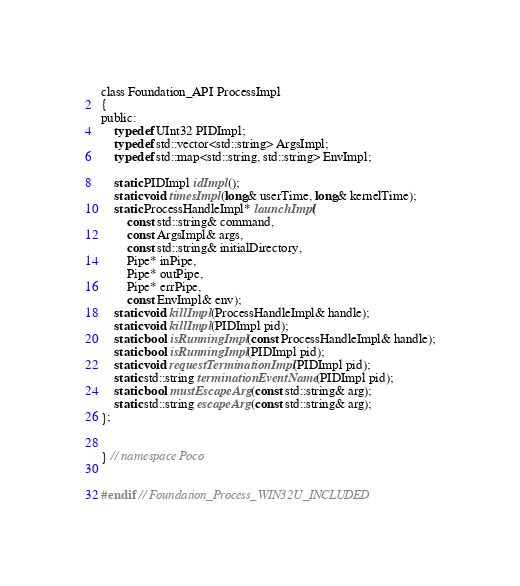<code> <loc_0><loc_0><loc_500><loc_500><_C_>
class Foundation_API ProcessImpl
{
public:
	typedef UInt32 PIDImpl;
	typedef std::vector<std::string> ArgsImpl;
	typedef std::map<std::string, std::string> EnvImpl;

	static PIDImpl idImpl();
	static void timesImpl(long& userTime, long& kernelTime);
	static ProcessHandleImpl* launchImpl(
		const std::string& command,
		const ArgsImpl& args,
		const std::string& initialDirectory,
		Pipe* inPipe,
		Pipe* outPipe,
		Pipe* errPipe,
		const EnvImpl& env);
	static void killImpl(ProcessHandleImpl& handle);
	static void killImpl(PIDImpl pid);
	static bool isRunningImpl(const ProcessHandleImpl& handle);
	static bool isRunningImpl(PIDImpl pid);
	static void requestTerminationImpl(PIDImpl pid);
	static std::string terminationEventName(PIDImpl pid);
	static bool mustEscapeArg(const std::string& arg);
	static std::string escapeArg(const std::string& arg);
};


} // namespace Poco


#endif // Foundation_Process_WIN32U_INCLUDED
</code> 